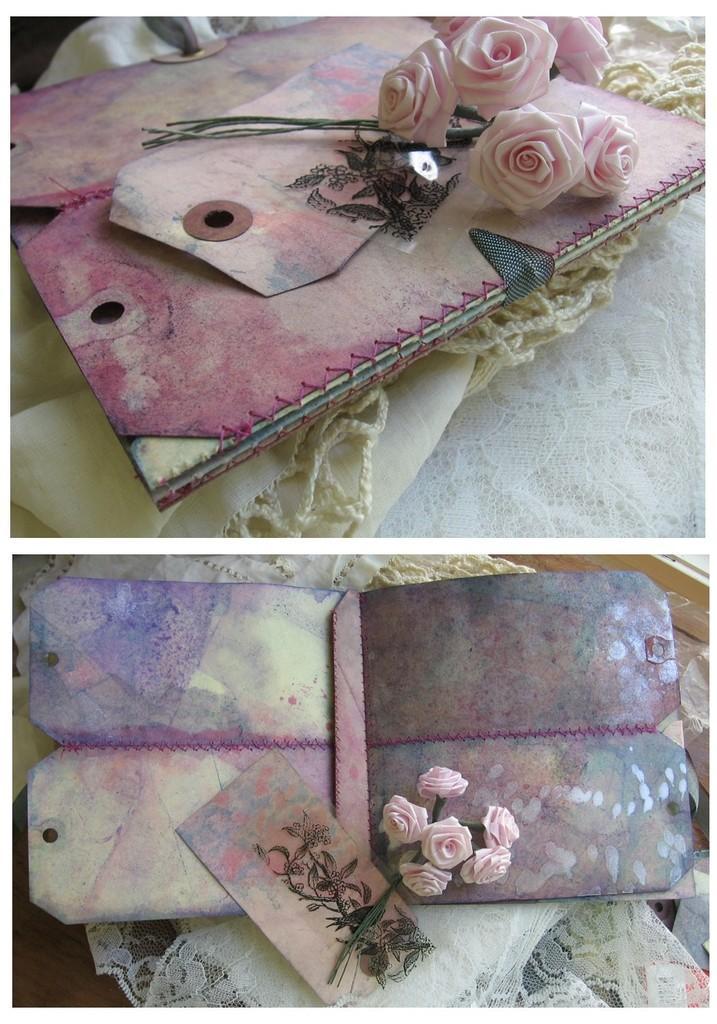Please provide a concise description of this image. This is a collage image and here we can see a dairy, some roses and a cloth. 